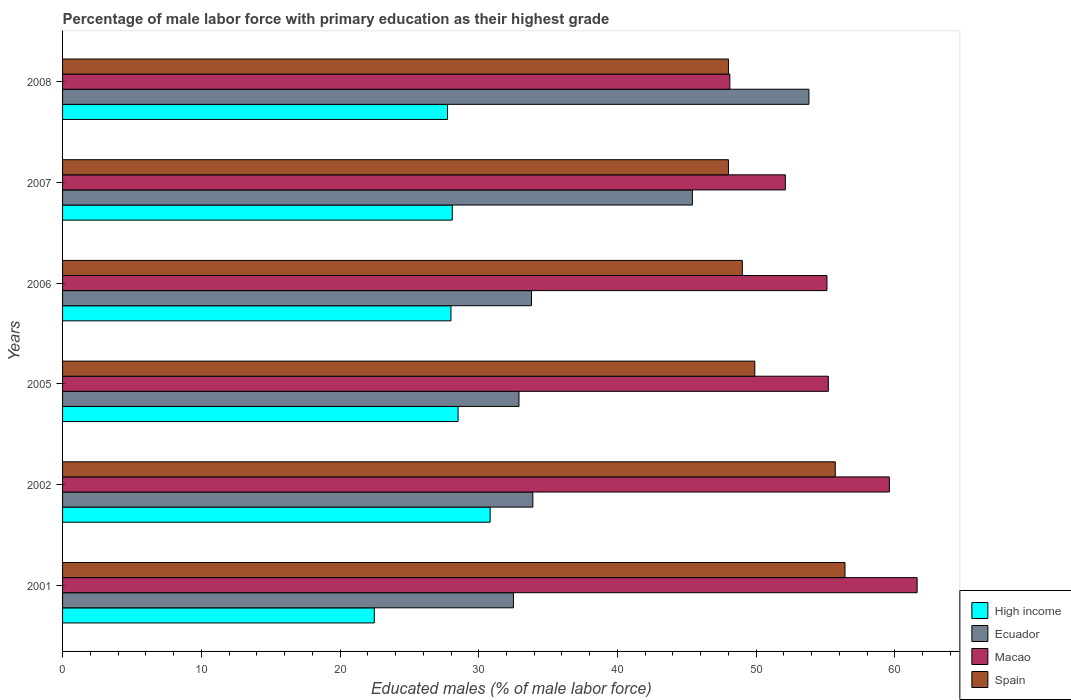How many different coloured bars are there?
Ensure brevity in your answer.  4. How many groups of bars are there?
Offer a very short reply. 6. Are the number of bars on each tick of the Y-axis equal?
Your response must be concise. Yes. How many bars are there on the 4th tick from the top?
Make the answer very short. 4. What is the label of the 1st group of bars from the top?
Your answer should be very brief. 2008. What is the percentage of male labor force with primary education in Spain in 2008?
Make the answer very short. 48. Across all years, what is the maximum percentage of male labor force with primary education in Ecuador?
Give a very brief answer. 53.8. Across all years, what is the minimum percentage of male labor force with primary education in Ecuador?
Ensure brevity in your answer.  32.5. In which year was the percentage of male labor force with primary education in High income maximum?
Provide a short and direct response. 2002. What is the total percentage of male labor force with primary education in High income in the graph?
Your answer should be compact. 165.64. What is the difference between the percentage of male labor force with primary education in Spain in 2005 and the percentage of male labor force with primary education in Ecuador in 2001?
Provide a succinct answer. 17.4. What is the average percentage of male labor force with primary education in Ecuador per year?
Offer a terse response. 38.72. In the year 2001, what is the difference between the percentage of male labor force with primary education in Ecuador and percentage of male labor force with primary education in Macao?
Make the answer very short. -29.1. What is the ratio of the percentage of male labor force with primary education in High income in 2001 to that in 2002?
Provide a succinct answer. 0.73. Is the percentage of male labor force with primary education in Spain in 2002 less than that in 2008?
Give a very brief answer. No. Is the difference between the percentage of male labor force with primary education in Ecuador in 2001 and 2007 greater than the difference between the percentage of male labor force with primary education in Macao in 2001 and 2007?
Provide a succinct answer. No. What is the difference between the highest and the lowest percentage of male labor force with primary education in Ecuador?
Your answer should be compact. 21.3. Is the sum of the percentage of male labor force with primary education in Spain in 2005 and 2006 greater than the maximum percentage of male labor force with primary education in High income across all years?
Ensure brevity in your answer.  Yes. Is it the case that in every year, the sum of the percentage of male labor force with primary education in Spain and percentage of male labor force with primary education in High income is greater than the sum of percentage of male labor force with primary education in Macao and percentage of male labor force with primary education in Ecuador?
Offer a very short reply. No. What does the 1st bar from the top in 2002 represents?
Offer a terse response. Spain. What does the 3rd bar from the bottom in 2002 represents?
Provide a succinct answer. Macao. Is it the case that in every year, the sum of the percentage of male labor force with primary education in Ecuador and percentage of male labor force with primary education in High income is greater than the percentage of male labor force with primary education in Spain?
Offer a very short reply. No. How many bars are there?
Your response must be concise. 24. Are all the bars in the graph horizontal?
Your response must be concise. Yes. How many years are there in the graph?
Offer a terse response. 6. What is the difference between two consecutive major ticks on the X-axis?
Keep it short and to the point. 10. Does the graph contain grids?
Your answer should be compact. No. Where does the legend appear in the graph?
Give a very brief answer. Bottom right. How many legend labels are there?
Provide a succinct answer. 4. What is the title of the graph?
Your response must be concise. Percentage of male labor force with primary education as their highest grade. Does "China" appear as one of the legend labels in the graph?
Give a very brief answer. No. What is the label or title of the X-axis?
Ensure brevity in your answer.  Educated males (% of male labor force). What is the Educated males (% of male labor force) of High income in 2001?
Your answer should be very brief. 22.47. What is the Educated males (% of male labor force) of Ecuador in 2001?
Keep it short and to the point. 32.5. What is the Educated males (% of male labor force) in Macao in 2001?
Your answer should be very brief. 61.6. What is the Educated males (% of male labor force) in Spain in 2001?
Your response must be concise. 56.4. What is the Educated males (% of male labor force) of High income in 2002?
Provide a succinct answer. 30.82. What is the Educated males (% of male labor force) in Ecuador in 2002?
Provide a short and direct response. 33.9. What is the Educated males (% of male labor force) of Macao in 2002?
Ensure brevity in your answer.  59.6. What is the Educated males (% of male labor force) in Spain in 2002?
Provide a short and direct response. 55.7. What is the Educated males (% of male labor force) of High income in 2005?
Offer a terse response. 28.51. What is the Educated males (% of male labor force) of Ecuador in 2005?
Offer a very short reply. 32.9. What is the Educated males (% of male labor force) in Macao in 2005?
Provide a succinct answer. 55.2. What is the Educated males (% of male labor force) in Spain in 2005?
Make the answer very short. 49.9. What is the Educated males (% of male labor force) in High income in 2006?
Offer a terse response. 28. What is the Educated males (% of male labor force) in Ecuador in 2006?
Your response must be concise. 33.8. What is the Educated males (% of male labor force) in Macao in 2006?
Your answer should be very brief. 55.1. What is the Educated males (% of male labor force) of Spain in 2006?
Your answer should be very brief. 49. What is the Educated males (% of male labor force) of High income in 2007?
Your answer should be compact. 28.09. What is the Educated males (% of male labor force) of Ecuador in 2007?
Your answer should be compact. 45.4. What is the Educated males (% of male labor force) of Macao in 2007?
Give a very brief answer. 52.1. What is the Educated males (% of male labor force) in Spain in 2007?
Provide a short and direct response. 48. What is the Educated males (% of male labor force) in High income in 2008?
Give a very brief answer. 27.75. What is the Educated males (% of male labor force) of Ecuador in 2008?
Keep it short and to the point. 53.8. What is the Educated males (% of male labor force) in Macao in 2008?
Make the answer very short. 48.1. What is the Educated males (% of male labor force) in Spain in 2008?
Give a very brief answer. 48. Across all years, what is the maximum Educated males (% of male labor force) of High income?
Provide a short and direct response. 30.82. Across all years, what is the maximum Educated males (% of male labor force) of Ecuador?
Provide a short and direct response. 53.8. Across all years, what is the maximum Educated males (% of male labor force) in Macao?
Give a very brief answer. 61.6. Across all years, what is the maximum Educated males (% of male labor force) of Spain?
Give a very brief answer. 56.4. Across all years, what is the minimum Educated males (% of male labor force) of High income?
Your answer should be compact. 22.47. Across all years, what is the minimum Educated males (% of male labor force) in Ecuador?
Make the answer very short. 32.5. Across all years, what is the minimum Educated males (% of male labor force) in Macao?
Ensure brevity in your answer.  48.1. What is the total Educated males (% of male labor force) in High income in the graph?
Your answer should be very brief. 165.64. What is the total Educated males (% of male labor force) in Ecuador in the graph?
Offer a very short reply. 232.3. What is the total Educated males (% of male labor force) of Macao in the graph?
Offer a terse response. 331.7. What is the total Educated males (% of male labor force) in Spain in the graph?
Keep it short and to the point. 307. What is the difference between the Educated males (% of male labor force) in High income in 2001 and that in 2002?
Offer a very short reply. -8.35. What is the difference between the Educated males (% of male labor force) of Macao in 2001 and that in 2002?
Offer a very short reply. 2. What is the difference between the Educated males (% of male labor force) of High income in 2001 and that in 2005?
Provide a short and direct response. -6.04. What is the difference between the Educated males (% of male labor force) of Macao in 2001 and that in 2005?
Make the answer very short. 6.4. What is the difference between the Educated males (% of male labor force) in High income in 2001 and that in 2006?
Your response must be concise. -5.53. What is the difference between the Educated males (% of male labor force) of Macao in 2001 and that in 2006?
Your answer should be very brief. 6.5. What is the difference between the Educated males (% of male labor force) of Spain in 2001 and that in 2006?
Keep it short and to the point. 7.4. What is the difference between the Educated males (% of male labor force) in High income in 2001 and that in 2007?
Provide a short and direct response. -5.62. What is the difference between the Educated males (% of male labor force) in Ecuador in 2001 and that in 2007?
Your answer should be compact. -12.9. What is the difference between the Educated males (% of male labor force) in Macao in 2001 and that in 2007?
Offer a terse response. 9.5. What is the difference between the Educated males (% of male labor force) in Spain in 2001 and that in 2007?
Provide a succinct answer. 8.4. What is the difference between the Educated males (% of male labor force) of High income in 2001 and that in 2008?
Give a very brief answer. -5.28. What is the difference between the Educated males (% of male labor force) in Ecuador in 2001 and that in 2008?
Provide a succinct answer. -21.3. What is the difference between the Educated males (% of male labor force) of High income in 2002 and that in 2005?
Keep it short and to the point. 2.31. What is the difference between the Educated males (% of male labor force) in Ecuador in 2002 and that in 2005?
Your answer should be very brief. 1. What is the difference between the Educated males (% of male labor force) in Macao in 2002 and that in 2005?
Provide a short and direct response. 4.4. What is the difference between the Educated males (% of male labor force) in Spain in 2002 and that in 2005?
Ensure brevity in your answer.  5.8. What is the difference between the Educated males (% of male labor force) of High income in 2002 and that in 2006?
Your answer should be very brief. 2.82. What is the difference between the Educated males (% of male labor force) of Ecuador in 2002 and that in 2006?
Provide a succinct answer. 0.1. What is the difference between the Educated males (% of male labor force) of Spain in 2002 and that in 2006?
Provide a succinct answer. 6.7. What is the difference between the Educated males (% of male labor force) in High income in 2002 and that in 2007?
Keep it short and to the point. 2.73. What is the difference between the Educated males (% of male labor force) in Ecuador in 2002 and that in 2007?
Provide a succinct answer. -11.5. What is the difference between the Educated males (% of male labor force) of Spain in 2002 and that in 2007?
Offer a terse response. 7.7. What is the difference between the Educated males (% of male labor force) in High income in 2002 and that in 2008?
Give a very brief answer. 3.07. What is the difference between the Educated males (% of male labor force) of Ecuador in 2002 and that in 2008?
Keep it short and to the point. -19.9. What is the difference between the Educated males (% of male labor force) in Macao in 2002 and that in 2008?
Provide a short and direct response. 11.5. What is the difference between the Educated males (% of male labor force) of Spain in 2002 and that in 2008?
Keep it short and to the point. 7.7. What is the difference between the Educated males (% of male labor force) of High income in 2005 and that in 2006?
Keep it short and to the point. 0.51. What is the difference between the Educated males (% of male labor force) in Ecuador in 2005 and that in 2006?
Provide a succinct answer. -0.9. What is the difference between the Educated males (% of male labor force) of Spain in 2005 and that in 2006?
Keep it short and to the point. 0.9. What is the difference between the Educated males (% of male labor force) in High income in 2005 and that in 2007?
Offer a terse response. 0.42. What is the difference between the Educated males (% of male labor force) of Ecuador in 2005 and that in 2007?
Make the answer very short. -12.5. What is the difference between the Educated males (% of male labor force) of Macao in 2005 and that in 2007?
Offer a terse response. 3.1. What is the difference between the Educated males (% of male labor force) of Spain in 2005 and that in 2007?
Give a very brief answer. 1.9. What is the difference between the Educated males (% of male labor force) of High income in 2005 and that in 2008?
Offer a very short reply. 0.76. What is the difference between the Educated males (% of male labor force) of Ecuador in 2005 and that in 2008?
Your answer should be compact. -20.9. What is the difference between the Educated males (% of male labor force) of Macao in 2005 and that in 2008?
Keep it short and to the point. 7.1. What is the difference between the Educated males (% of male labor force) in High income in 2006 and that in 2007?
Make the answer very short. -0.09. What is the difference between the Educated males (% of male labor force) in High income in 2006 and that in 2008?
Your answer should be compact. 0.25. What is the difference between the Educated males (% of male labor force) in Macao in 2006 and that in 2008?
Ensure brevity in your answer.  7. What is the difference between the Educated males (% of male labor force) of High income in 2007 and that in 2008?
Give a very brief answer. 0.34. What is the difference between the Educated males (% of male labor force) in Macao in 2007 and that in 2008?
Keep it short and to the point. 4. What is the difference between the Educated males (% of male labor force) of Spain in 2007 and that in 2008?
Offer a very short reply. 0. What is the difference between the Educated males (% of male labor force) of High income in 2001 and the Educated males (% of male labor force) of Ecuador in 2002?
Provide a succinct answer. -11.43. What is the difference between the Educated males (% of male labor force) in High income in 2001 and the Educated males (% of male labor force) in Macao in 2002?
Offer a terse response. -37.13. What is the difference between the Educated males (% of male labor force) in High income in 2001 and the Educated males (% of male labor force) in Spain in 2002?
Your response must be concise. -33.23. What is the difference between the Educated males (% of male labor force) in Ecuador in 2001 and the Educated males (% of male labor force) in Macao in 2002?
Your answer should be very brief. -27.1. What is the difference between the Educated males (% of male labor force) in Ecuador in 2001 and the Educated males (% of male labor force) in Spain in 2002?
Offer a terse response. -23.2. What is the difference between the Educated males (% of male labor force) in Macao in 2001 and the Educated males (% of male labor force) in Spain in 2002?
Offer a very short reply. 5.9. What is the difference between the Educated males (% of male labor force) of High income in 2001 and the Educated males (% of male labor force) of Ecuador in 2005?
Offer a very short reply. -10.43. What is the difference between the Educated males (% of male labor force) of High income in 2001 and the Educated males (% of male labor force) of Macao in 2005?
Keep it short and to the point. -32.73. What is the difference between the Educated males (% of male labor force) in High income in 2001 and the Educated males (% of male labor force) in Spain in 2005?
Your answer should be very brief. -27.43. What is the difference between the Educated males (% of male labor force) of Ecuador in 2001 and the Educated males (% of male labor force) of Macao in 2005?
Your answer should be very brief. -22.7. What is the difference between the Educated males (% of male labor force) of Ecuador in 2001 and the Educated males (% of male labor force) of Spain in 2005?
Your answer should be very brief. -17.4. What is the difference between the Educated males (% of male labor force) in Macao in 2001 and the Educated males (% of male labor force) in Spain in 2005?
Your response must be concise. 11.7. What is the difference between the Educated males (% of male labor force) of High income in 2001 and the Educated males (% of male labor force) of Ecuador in 2006?
Make the answer very short. -11.33. What is the difference between the Educated males (% of male labor force) of High income in 2001 and the Educated males (% of male labor force) of Macao in 2006?
Your answer should be very brief. -32.63. What is the difference between the Educated males (% of male labor force) of High income in 2001 and the Educated males (% of male labor force) of Spain in 2006?
Keep it short and to the point. -26.53. What is the difference between the Educated males (% of male labor force) in Ecuador in 2001 and the Educated males (% of male labor force) in Macao in 2006?
Give a very brief answer. -22.6. What is the difference between the Educated males (% of male labor force) in Ecuador in 2001 and the Educated males (% of male labor force) in Spain in 2006?
Offer a terse response. -16.5. What is the difference between the Educated males (% of male labor force) of High income in 2001 and the Educated males (% of male labor force) of Ecuador in 2007?
Give a very brief answer. -22.93. What is the difference between the Educated males (% of male labor force) in High income in 2001 and the Educated males (% of male labor force) in Macao in 2007?
Give a very brief answer. -29.63. What is the difference between the Educated males (% of male labor force) of High income in 2001 and the Educated males (% of male labor force) of Spain in 2007?
Your answer should be compact. -25.53. What is the difference between the Educated males (% of male labor force) in Ecuador in 2001 and the Educated males (% of male labor force) in Macao in 2007?
Your answer should be compact. -19.6. What is the difference between the Educated males (% of male labor force) of Ecuador in 2001 and the Educated males (% of male labor force) of Spain in 2007?
Make the answer very short. -15.5. What is the difference between the Educated males (% of male labor force) of High income in 2001 and the Educated males (% of male labor force) of Ecuador in 2008?
Keep it short and to the point. -31.33. What is the difference between the Educated males (% of male labor force) of High income in 2001 and the Educated males (% of male labor force) of Macao in 2008?
Offer a terse response. -25.63. What is the difference between the Educated males (% of male labor force) of High income in 2001 and the Educated males (% of male labor force) of Spain in 2008?
Make the answer very short. -25.53. What is the difference between the Educated males (% of male labor force) of Ecuador in 2001 and the Educated males (% of male labor force) of Macao in 2008?
Provide a short and direct response. -15.6. What is the difference between the Educated males (% of male labor force) in Ecuador in 2001 and the Educated males (% of male labor force) in Spain in 2008?
Make the answer very short. -15.5. What is the difference between the Educated males (% of male labor force) of High income in 2002 and the Educated males (% of male labor force) of Ecuador in 2005?
Give a very brief answer. -2.08. What is the difference between the Educated males (% of male labor force) in High income in 2002 and the Educated males (% of male labor force) in Macao in 2005?
Keep it short and to the point. -24.38. What is the difference between the Educated males (% of male labor force) in High income in 2002 and the Educated males (% of male labor force) in Spain in 2005?
Provide a short and direct response. -19.08. What is the difference between the Educated males (% of male labor force) of Ecuador in 2002 and the Educated males (% of male labor force) of Macao in 2005?
Give a very brief answer. -21.3. What is the difference between the Educated males (% of male labor force) of High income in 2002 and the Educated males (% of male labor force) of Ecuador in 2006?
Your response must be concise. -2.98. What is the difference between the Educated males (% of male labor force) in High income in 2002 and the Educated males (% of male labor force) in Macao in 2006?
Offer a terse response. -24.28. What is the difference between the Educated males (% of male labor force) in High income in 2002 and the Educated males (% of male labor force) in Spain in 2006?
Offer a terse response. -18.18. What is the difference between the Educated males (% of male labor force) of Ecuador in 2002 and the Educated males (% of male labor force) of Macao in 2006?
Your answer should be very brief. -21.2. What is the difference between the Educated males (% of male labor force) of Ecuador in 2002 and the Educated males (% of male labor force) of Spain in 2006?
Your response must be concise. -15.1. What is the difference between the Educated males (% of male labor force) in Macao in 2002 and the Educated males (% of male labor force) in Spain in 2006?
Ensure brevity in your answer.  10.6. What is the difference between the Educated males (% of male labor force) in High income in 2002 and the Educated males (% of male labor force) in Ecuador in 2007?
Your answer should be very brief. -14.58. What is the difference between the Educated males (% of male labor force) in High income in 2002 and the Educated males (% of male labor force) in Macao in 2007?
Ensure brevity in your answer.  -21.28. What is the difference between the Educated males (% of male labor force) of High income in 2002 and the Educated males (% of male labor force) of Spain in 2007?
Provide a short and direct response. -17.18. What is the difference between the Educated males (% of male labor force) of Ecuador in 2002 and the Educated males (% of male labor force) of Macao in 2007?
Provide a short and direct response. -18.2. What is the difference between the Educated males (% of male labor force) of Ecuador in 2002 and the Educated males (% of male labor force) of Spain in 2007?
Your response must be concise. -14.1. What is the difference between the Educated males (% of male labor force) of Macao in 2002 and the Educated males (% of male labor force) of Spain in 2007?
Your answer should be very brief. 11.6. What is the difference between the Educated males (% of male labor force) of High income in 2002 and the Educated males (% of male labor force) of Ecuador in 2008?
Offer a very short reply. -22.98. What is the difference between the Educated males (% of male labor force) in High income in 2002 and the Educated males (% of male labor force) in Macao in 2008?
Ensure brevity in your answer.  -17.28. What is the difference between the Educated males (% of male labor force) in High income in 2002 and the Educated males (% of male labor force) in Spain in 2008?
Give a very brief answer. -17.18. What is the difference between the Educated males (% of male labor force) of Ecuador in 2002 and the Educated males (% of male labor force) of Spain in 2008?
Make the answer very short. -14.1. What is the difference between the Educated males (% of male labor force) of Macao in 2002 and the Educated males (% of male labor force) of Spain in 2008?
Your answer should be very brief. 11.6. What is the difference between the Educated males (% of male labor force) in High income in 2005 and the Educated males (% of male labor force) in Ecuador in 2006?
Offer a very short reply. -5.29. What is the difference between the Educated males (% of male labor force) of High income in 2005 and the Educated males (% of male labor force) of Macao in 2006?
Your response must be concise. -26.59. What is the difference between the Educated males (% of male labor force) of High income in 2005 and the Educated males (% of male labor force) of Spain in 2006?
Your answer should be compact. -20.49. What is the difference between the Educated males (% of male labor force) in Ecuador in 2005 and the Educated males (% of male labor force) in Macao in 2006?
Offer a very short reply. -22.2. What is the difference between the Educated males (% of male labor force) in Ecuador in 2005 and the Educated males (% of male labor force) in Spain in 2006?
Offer a terse response. -16.1. What is the difference between the Educated males (% of male labor force) in High income in 2005 and the Educated males (% of male labor force) in Ecuador in 2007?
Make the answer very short. -16.89. What is the difference between the Educated males (% of male labor force) of High income in 2005 and the Educated males (% of male labor force) of Macao in 2007?
Give a very brief answer. -23.59. What is the difference between the Educated males (% of male labor force) of High income in 2005 and the Educated males (% of male labor force) of Spain in 2007?
Provide a succinct answer. -19.49. What is the difference between the Educated males (% of male labor force) of Ecuador in 2005 and the Educated males (% of male labor force) of Macao in 2007?
Make the answer very short. -19.2. What is the difference between the Educated males (% of male labor force) of Ecuador in 2005 and the Educated males (% of male labor force) of Spain in 2007?
Offer a very short reply. -15.1. What is the difference between the Educated males (% of male labor force) of Macao in 2005 and the Educated males (% of male labor force) of Spain in 2007?
Your answer should be compact. 7.2. What is the difference between the Educated males (% of male labor force) in High income in 2005 and the Educated males (% of male labor force) in Ecuador in 2008?
Your response must be concise. -25.29. What is the difference between the Educated males (% of male labor force) in High income in 2005 and the Educated males (% of male labor force) in Macao in 2008?
Keep it short and to the point. -19.59. What is the difference between the Educated males (% of male labor force) of High income in 2005 and the Educated males (% of male labor force) of Spain in 2008?
Ensure brevity in your answer.  -19.49. What is the difference between the Educated males (% of male labor force) of Ecuador in 2005 and the Educated males (% of male labor force) of Macao in 2008?
Offer a very short reply. -15.2. What is the difference between the Educated males (% of male labor force) in Ecuador in 2005 and the Educated males (% of male labor force) in Spain in 2008?
Make the answer very short. -15.1. What is the difference between the Educated males (% of male labor force) in High income in 2006 and the Educated males (% of male labor force) in Ecuador in 2007?
Offer a very short reply. -17.4. What is the difference between the Educated males (% of male labor force) in High income in 2006 and the Educated males (% of male labor force) in Macao in 2007?
Offer a very short reply. -24.1. What is the difference between the Educated males (% of male labor force) of High income in 2006 and the Educated males (% of male labor force) of Spain in 2007?
Your answer should be very brief. -20. What is the difference between the Educated males (% of male labor force) in Ecuador in 2006 and the Educated males (% of male labor force) in Macao in 2007?
Provide a short and direct response. -18.3. What is the difference between the Educated males (% of male labor force) of High income in 2006 and the Educated males (% of male labor force) of Ecuador in 2008?
Your answer should be compact. -25.8. What is the difference between the Educated males (% of male labor force) in High income in 2006 and the Educated males (% of male labor force) in Macao in 2008?
Provide a succinct answer. -20.1. What is the difference between the Educated males (% of male labor force) of High income in 2006 and the Educated males (% of male labor force) of Spain in 2008?
Provide a succinct answer. -20. What is the difference between the Educated males (% of male labor force) of Ecuador in 2006 and the Educated males (% of male labor force) of Macao in 2008?
Give a very brief answer. -14.3. What is the difference between the Educated males (% of male labor force) of Ecuador in 2006 and the Educated males (% of male labor force) of Spain in 2008?
Make the answer very short. -14.2. What is the difference between the Educated males (% of male labor force) in Macao in 2006 and the Educated males (% of male labor force) in Spain in 2008?
Ensure brevity in your answer.  7.1. What is the difference between the Educated males (% of male labor force) in High income in 2007 and the Educated males (% of male labor force) in Ecuador in 2008?
Ensure brevity in your answer.  -25.71. What is the difference between the Educated males (% of male labor force) of High income in 2007 and the Educated males (% of male labor force) of Macao in 2008?
Your answer should be very brief. -20.01. What is the difference between the Educated males (% of male labor force) in High income in 2007 and the Educated males (% of male labor force) in Spain in 2008?
Your answer should be compact. -19.91. What is the difference between the Educated males (% of male labor force) of Ecuador in 2007 and the Educated males (% of male labor force) of Macao in 2008?
Offer a terse response. -2.7. What is the average Educated males (% of male labor force) in High income per year?
Keep it short and to the point. 27.61. What is the average Educated males (% of male labor force) in Ecuador per year?
Provide a succinct answer. 38.72. What is the average Educated males (% of male labor force) in Macao per year?
Provide a short and direct response. 55.28. What is the average Educated males (% of male labor force) in Spain per year?
Offer a terse response. 51.17. In the year 2001, what is the difference between the Educated males (% of male labor force) in High income and Educated males (% of male labor force) in Ecuador?
Make the answer very short. -10.03. In the year 2001, what is the difference between the Educated males (% of male labor force) of High income and Educated males (% of male labor force) of Macao?
Keep it short and to the point. -39.13. In the year 2001, what is the difference between the Educated males (% of male labor force) of High income and Educated males (% of male labor force) of Spain?
Your answer should be very brief. -33.93. In the year 2001, what is the difference between the Educated males (% of male labor force) of Ecuador and Educated males (% of male labor force) of Macao?
Give a very brief answer. -29.1. In the year 2001, what is the difference between the Educated males (% of male labor force) in Ecuador and Educated males (% of male labor force) in Spain?
Ensure brevity in your answer.  -23.9. In the year 2002, what is the difference between the Educated males (% of male labor force) in High income and Educated males (% of male labor force) in Ecuador?
Your answer should be very brief. -3.08. In the year 2002, what is the difference between the Educated males (% of male labor force) in High income and Educated males (% of male labor force) in Macao?
Offer a very short reply. -28.78. In the year 2002, what is the difference between the Educated males (% of male labor force) in High income and Educated males (% of male labor force) in Spain?
Keep it short and to the point. -24.88. In the year 2002, what is the difference between the Educated males (% of male labor force) of Ecuador and Educated males (% of male labor force) of Macao?
Your answer should be compact. -25.7. In the year 2002, what is the difference between the Educated males (% of male labor force) in Ecuador and Educated males (% of male labor force) in Spain?
Your answer should be very brief. -21.8. In the year 2002, what is the difference between the Educated males (% of male labor force) of Macao and Educated males (% of male labor force) of Spain?
Offer a very short reply. 3.9. In the year 2005, what is the difference between the Educated males (% of male labor force) of High income and Educated males (% of male labor force) of Ecuador?
Offer a terse response. -4.39. In the year 2005, what is the difference between the Educated males (% of male labor force) in High income and Educated males (% of male labor force) in Macao?
Provide a succinct answer. -26.69. In the year 2005, what is the difference between the Educated males (% of male labor force) of High income and Educated males (% of male labor force) of Spain?
Give a very brief answer. -21.39. In the year 2005, what is the difference between the Educated males (% of male labor force) of Ecuador and Educated males (% of male labor force) of Macao?
Provide a succinct answer. -22.3. In the year 2005, what is the difference between the Educated males (% of male labor force) in Ecuador and Educated males (% of male labor force) in Spain?
Your answer should be very brief. -17. In the year 2006, what is the difference between the Educated males (% of male labor force) of High income and Educated males (% of male labor force) of Ecuador?
Provide a succinct answer. -5.8. In the year 2006, what is the difference between the Educated males (% of male labor force) of High income and Educated males (% of male labor force) of Macao?
Provide a short and direct response. -27.1. In the year 2006, what is the difference between the Educated males (% of male labor force) of High income and Educated males (% of male labor force) of Spain?
Offer a terse response. -21. In the year 2006, what is the difference between the Educated males (% of male labor force) of Ecuador and Educated males (% of male labor force) of Macao?
Make the answer very short. -21.3. In the year 2006, what is the difference between the Educated males (% of male labor force) in Ecuador and Educated males (% of male labor force) in Spain?
Make the answer very short. -15.2. In the year 2007, what is the difference between the Educated males (% of male labor force) of High income and Educated males (% of male labor force) of Ecuador?
Offer a very short reply. -17.31. In the year 2007, what is the difference between the Educated males (% of male labor force) of High income and Educated males (% of male labor force) of Macao?
Keep it short and to the point. -24.01. In the year 2007, what is the difference between the Educated males (% of male labor force) in High income and Educated males (% of male labor force) in Spain?
Your answer should be very brief. -19.91. In the year 2007, what is the difference between the Educated males (% of male labor force) in Ecuador and Educated males (% of male labor force) in Spain?
Ensure brevity in your answer.  -2.6. In the year 2007, what is the difference between the Educated males (% of male labor force) in Macao and Educated males (% of male labor force) in Spain?
Keep it short and to the point. 4.1. In the year 2008, what is the difference between the Educated males (% of male labor force) of High income and Educated males (% of male labor force) of Ecuador?
Offer a very short reply. -26.05. In the year 2008, what is the difference between the Educated males (% of male labor force) in High income and Educated males (% of male labor force) in Macao?
Your answer should be compact. -20.35. In the year 2008, what is the difference between the Educated males (% of male labor force) in High income and Educated males (% of male labor force) in Spain?
Offer a very short reply. -20.25. In the year 2008, what is the difference between the Educated males (% of male labor force) in Ecuador and Educated males (% of male labor force) in Macao?
Make the answer very short. 5.7. In the year 2008, what is the difference between the Educated males (% of male labor force) of Ecuador and Educated males (% of male labor force) of Spain?
Ensure brevity in your answer.  5.8. In the year 2008, what is the difference between the Educated males (% of male labor force) of Macao and Educated males (% of male labor force) of Spain?
Keep it short and to the point. 0.1. What is the ratio of the Educated males (% of male labor force) in High income in 2001 to that in 2002?
Provide a succinct answer. 0.73. What is the ratio of the Educated males (% of male labor force) of Ecuador in 2001 to that in 2002?
Ensure brevity in your answer.  0.96. What is the ratio of the Educated males (% of male labor force) in Macao in 2001 to that in 2002?
Keep it short and to the point. 1.03. What is the ratio of the Educated males (% of male labor force) in Spain in 2001 to that in 2002?
Provide a succinct answer. 1.01. What is the ratio of the Educated males (% of male labor force) in High income in 2001 to that in 2005?
Ensure brevity in your answer.  0.79. What is the ratio of the Educated males (% of male labor force) of Macao in 2001 to that in 2005?
Ensure brevity in your answer.  1.12. What is the ratio of the Educated males (% of male labor force) in Spain in 2001 to that in 2005?
Provide a succinct answer. 1.13. What is the ratio of the Educated males (% of male labor force) in High income in 2001 to that in 2006?
Make the answer very short. 0.8. What is the ratio of the Educated males (% of male labor force) in Ecuador in 2001 to that in 2006?
Provide a succinct answer. 0.96. What is the ratio of the Educated males (% of male labor force) in Macao in 2001 to that in 2006?
Provide a short and direct response. 1.12. What is the ratio of the Educated males (% of male labor force) of Spain in 2001 to that in 2006?
Your response must be concise. 1.15. What is the ratio of the Educated males (% of male labor force) of High income in 2001 to that in 2007?
Your answer should be compact. 0.8. What is the ratio of the Educated males (% of male labor force) in Ecuador in 2001 to that in 2007?
Keep it short and to the point. 0.72. What is the ratio of the Educated males (% of male labor force) in Macao in 2001 to that in 2007?
Ensure brevity in your answer.  1.18. What is the ratio of the Educated males (% of male labor force) in Spain in 2001 to that in 2007?
Give a very brief answer. 1.18. What is the ratio of the Educated males (% of male labor force) in High income in 2001 to that in 2008?
Keep it short and to the point. 0.81. What is the ratio of the Educated males (% of male labor force) of Ecuador in 2001 to that in 2008?
Your answer should be compact. 0.6. What is the ratio of the Educated males (% of male labor force) of Macao in 2001 to that in 2008?
Provide a succinct answer. 1.28. What is the ratio of the Educated males (% of male labor force) of Spain in 2001 to that in 2008?
Ensure brevity in your answer.  1.18. What is the ratio of the Educated males (% of male labor force) of High income in 2002 to that in 2005?
Keep it short and to the point. 1.08. What is the ratio of the Educated males (% of male labor force) of Ecuador in 2002 to that in 2005?
Provide a succinct answer. 1.03. What is the ratio of the Educated males (% of male labor force) in Macao in 2002 to that in 2005?
Your response must be concise. 1.08. What is the ratio of the Educated males (% of male labor force) in Spain in 2002 to that in 2005?
Your response must be concise. 1.12. What is the ratio of the Educated males (% of male labor force) of High income in 2002 to that in 2006?
Your answer should be very brief. 1.1. What is the ratio of the Educated males (% of male labor force) in Macao in 2002 to that in 2006?
Ensure brevity in your answer.  1.08. What is the ratio of the Educated males (% of male labor force) in Spain in 2002 to that in 2006?
Provide a succinct answer. 1.14. What is the ratio of the Educated males (% of male labor force) of High income in 2002 to that in 2007?
Provide a short and direct response. 1.1. What is the ratio of the Educated males (% of male labor force) of Ecuador in 2002 to that in 2007?
Your answer should be compact. 0.75. What is the ratio of the Educated males (% of male labor force) in Macao in 2002 to that in 2007?
Offer a very short reply. 1.14. What is the ratio of the Educated males (% of male labor force) in Spain in 2002 to that in 2007?
Offer a terse response. 1.16. What is the ratio of the Educated males (% of male labor force) in High income in 2002 to that in 2008?
Provide a short and direct response. 1.11. What is the ratio of the Educated males (% of male labor force) in Ecuador in 2002 to that in 2008?
Your answer should be compact. 0.63. What is the ratio of the Educated males (% of male labor force) in Macao in 2002 to that in 2008?
Provide a succinct answer. 1.24. What is the ratio of the Educated males (% of male labor force) of Spain in 2002 to that in 2008?
Provide a succinct answer. 1.16. What is the ratio of the Educated males (% of male labor force) of High income in 2005 to that in 2006?
Provide a short and direct response. 1.02. What is the ratio of the Educated males (% of male labor force) of Ecuador in 2005 to that in 2006?
Give a very brief answer. 0.97. What is the ratio of the Educated males (% of male labor force) of Macao in 2005 to that in 2006?
Offer a terse response. 1. What is the ratio of the Educated males (% of male labor force) in Spain in 2005 to that in 2006?
Provide a short and direct response. 1.02. What is the ratio of the Educated males (% of male labor force) of High income in 2005 to that in 2007?
Your answer should be very brief. 1.01. What is the ratio of the Educated males (% of male labor force) in Ecuador in 2005 to that in 2007?
Keep it short and to the point. 0.72. What is the ratio of the Educated males (% of male labor force) of Macao in 2005 to that in 2007?
Give a very brief answer. 1.06. What is the ratio of the Educated males (% of male labor force) of Spain in 2005 to that in 2007?
Give a very brief answer. 1.04. What is the ratio of the Educated males (% of male labor force) of High income in 2005 to that in 2008?
Your answer should be compact. 1.03. What is the ratio of the Educated males (% of male labor force) in Ecuador in 2005 to that in 2008?
Provide a succinct answer. 0.61. What is the ratio of the Educated males (% of male labor force) of Macao in 2005 to that in 2008?
Offer a terse response. 1.15. What is the ratio of the Educated males (% of male labor force) of Spain in 2005 to that in 2008?
Keep it short and to the point. 1.04. What is the ratio of the Educated males (% of male labor force) of Ecuador in 2006 to that in 2007?
Provide a short and direct response. 0.74. What is the ratio of the Educated males (% of male labor force) of Macao in 2006 to that in 2007?
Offer a very short reply. 1.06. What is the ratio of the Educated males (% of male labor force) of Spain in 2006 to that in 2007?
Offer a terse response. 1.02. What is the ratio of the Educated males (% of male labor force) of High income in 2006 to that in 2008?
Provide a succinct answer. 1.01. What is the ratio of the Educated males (% of male labor force) in Ecuador in 2006 to that in 2008?
Give a very brief answer. 0.63. What is the ratio of the Educated males (% of male labor force) in Macao in 2006 to that in 2008?
Your answer should be very brief. 1.15. What is the ratio of the Educated males (% of male labor force) of Spain in 2006 to that in 2008?
Provide a short and direct response. 1.02. What is the ratio of the Educated males (% of male labor force) of High income in 2007 to that in 2008?
Ensure brevity in your answer.  1.01. What is the ratio of the Educated males (% of male labor force) in Ecuador in 2007 to that in 2008?
Provide a succinct answer. 0.84. What is the ratio of the Educated males (% of male labor force) in Macao in 2007 to that in 2008?
Your answer should be compact. 1.08. What is the ratio of the Educated males (% of male labor force) in Spain in 2007 to that in 2008?
Your answer should be compact. 1. What is the difference between the highest and the second highest Educated males (% of male labor force) of High income?
Keep it short and to the point. 2.31. What is the difference between the highest and the second highest Educated males (% of male labor force) in Macao?
Make the answer very short. 2. What is the difference between the highest and the second highest Educated males (% of male labor force) in Spain?
Provide a succinct answer. 0.7. What is the difference between the highest and the lowest Educated males (% of male labor force) of High income?
Your answer should be compact. 8.35. What is the difference between the highest and the lowest Educated males (% of male labor force) in Ecuador?
Your answer should be compact. 21.3. What is the difference between the highest and the lowest Educated males (% of male labor force) of Spain?
Your response must be concise. 8.4. 